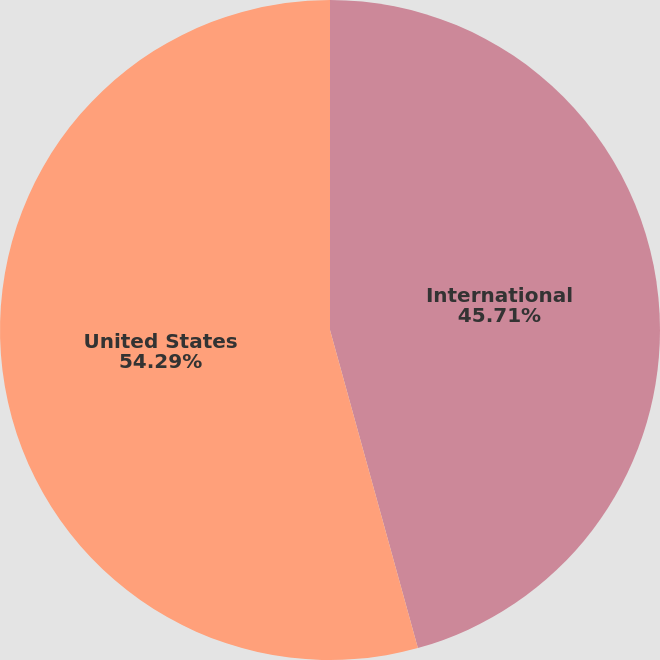Convert chart to OTSL. <chart><loc_0><loc_0><loc_500><loc_500><pie_chart><fcel>International<fcel>United States<nl><fcel>45.71%<fcel>54.29%<nl></chart> 